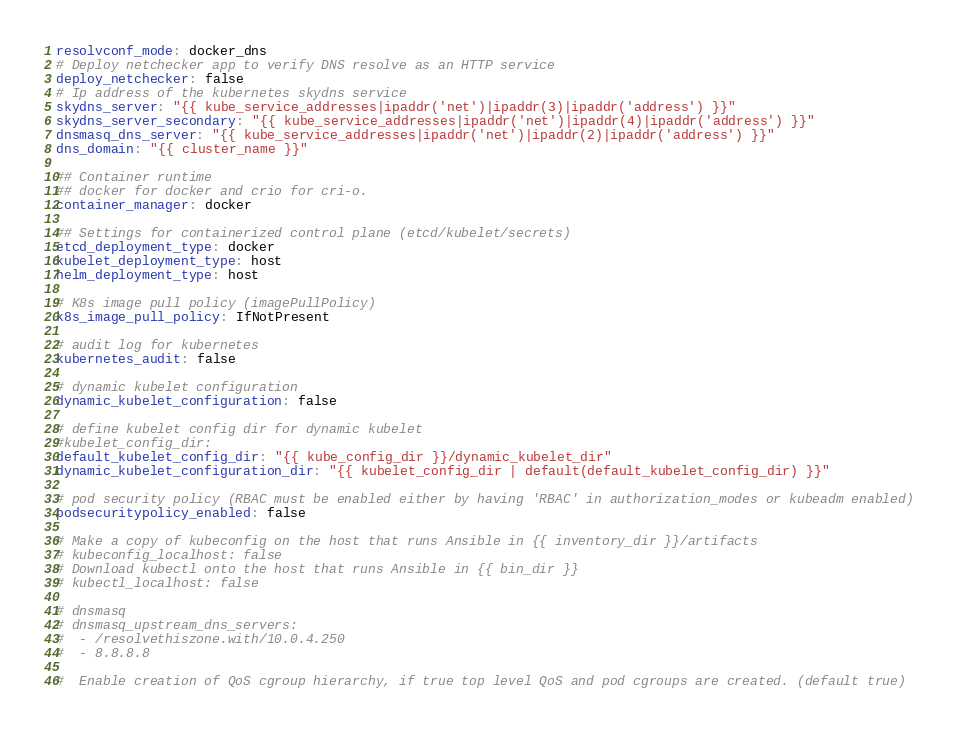<code> <loc_0><loc_0><loc_500><loc_500><_YAML_>resolvconf_mode: docker_dns
# Deploy netchecker app to verify DNS resolve as an HTTP service
deploy_netchecker: false
# Ip address of the kubernetes skydns service
skydns_server: "{{ kube_service_addresses|ipaddr('net')|ipaddr(3)|ipaddr('address') }}"
skydns_server_secondary: "{{ kube_service_addresses|ipaddr('net')|ipaddr(4)|ipaddr('address') }}"
dnsmasq_dns_server: "{{ kube_service_addresses|ipaddr('net')|ipaddr(2)|ipaddr('address') }}"
dns_domain: "{{ cluster_name }}"

## Container runtime
## docker for docker and crio for cri-o.
container_manager: docker

## Settings for containerized control plane (etcd/kubelet/secrets)
etcd_deployment_type: docker
kubelet_deployment_type: host
helm_deployment_type: host

# K8s image pull policy (imagePullPolicy)
k8s_image_pull_policy: IfNotPresent

# audit log for kubernetes
kubernetes_audit: false

# dynamic kubelet configuration
dynamic_kubelet_configuration: false

# define kubelet config dir for dynamic kubelet
#kubelet_config_dir:
default_kubelet_config_dir: "{{ kube_config_dir }}/dynamic_kubelet_dir"
dynamic_kubelet_configuration_dir: "{{ kubelet_config_dir | default(default_kubelet_config_dir) }}"

# pod security policy (RBAC must be enabled either by having 'RBAC' in authorization_modes or kubeadm enabled)
podsecuritypolicy_enabled: false

# Make a copy of kubeconfig on the host that runs Ansible in {{ inventory_dir }}/artifacts
# kubeconfig_localhost: false
# Download kubectl onto the host that runs Ansible in {{ bin_dir }}
# kubectl_localhost: false

# dnsmasq
# dnsmasq_upstream_dns_servers:
#  - /resolvethiszone.with/10.0.4.250
#  - 8.8.8.8

#  Enable creation of QoS cgroup hierarchy, if true top level QoS and pod cgroups are created. (default true)</code> 